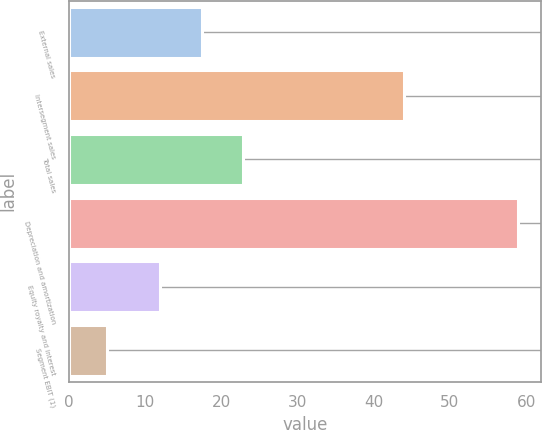Convert chart to OTSL. <chart><loc_0><loc_0><loc_500><loc_500><bar_chart><fcel>External sales<fcel>Intersegment sales<fcel>Total sales<fcel>Depreciation and amortization<fcel>Equity royalty and interest<fcel>Segment EBIT (1)<nl><fcel>17.4<fcel>44<fcel>22.8<fcel>59<fcel>12<fcel>5<nl></chart> 